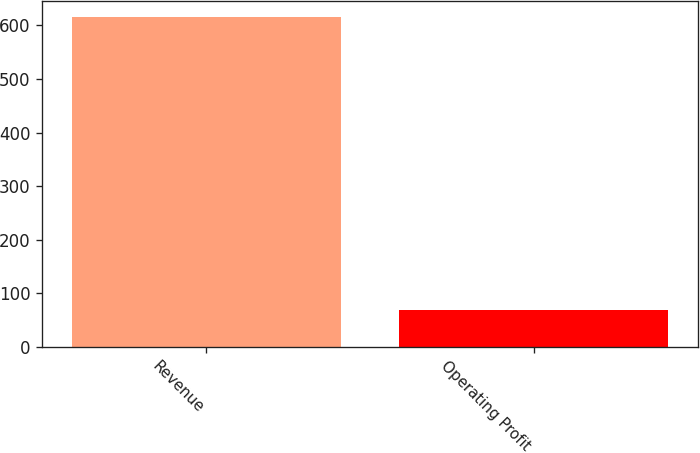<chart> <loc_0><loc_0><loc_500><loc_500><bar_chart><fcel>Revenue<fcel>Operating Profit<nl><fcel>615.1<fcel>69.5<nl></chart> 